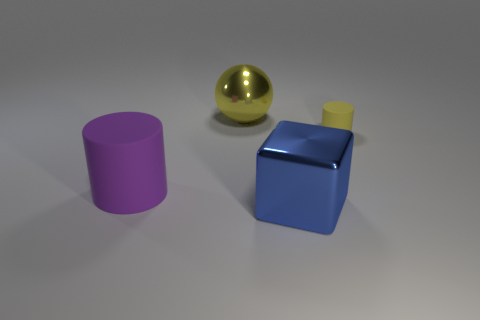There is a object that is both behind the big metallic cube and in front of the yellow cylinder; what is its shape?
Offer a very short reply. Cylinder. There is a large metal thing in front of the object that is behind the object to the right of the blue metal block; what shape is it?
Your response must be concise. Cube. What is the material of the object that is in front of the tiny thing and on the right side of the large rubber cylinder?
Make the answer very short. Metal. How many blue cylinders are the same size as the purple thing?
Offer a terse response. 0. How many shiny objects are either purple things or brown blocks?
Provide a short and direct response. 0. What is the yellow cylinder made of?
Your answer should be compact. Rubber. How many metal things are behind the big purple rubber object?
Offer a very short reply. 1. Is the cylinder right of the blue block made of the same material as the blue thing?
Your answer should be very brief. No. How many small rubber things are the same shape as the big blue object?
Make the answer very short. 0. How many tiny things are yellow shiny spheres or green matte cylinders?
Make the answer very short. 0. 